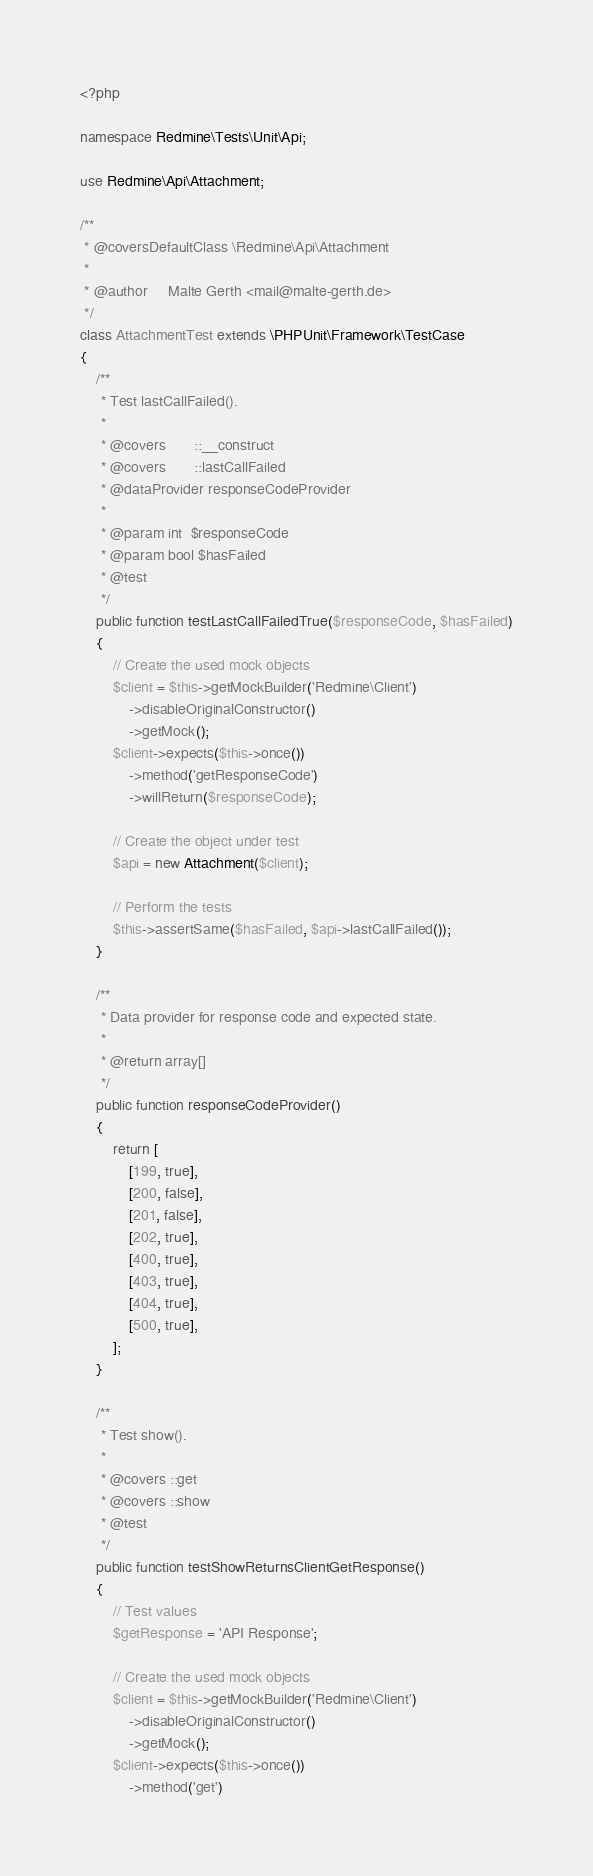Convert code to text. <code><loc_0><loc_0><loc_500><loc_500><_PHP_><?php

namespace Redmine\Tests\Unit\Api;

use Redmine\Api\Attachment;

/**
 * @coversDefaultClass \Redmine\Api\Attachment
 *
 * @author     Malte Gerth <mail@malte-gerth.de>
 */
class AttachmentTest extends \PHPUnit\Framework\TestCase
{
    /**
     * Test lastCallFailed().
     *
     * @covers       ::__construct
     * @covers       ::lastCallFailed
     * @dataProvider responseCodeProvider
     *
     * @param int  $responseCode
     * @param bool $hasFailed
     * @test
     */
    public function testLastCallFailedTrue($responseCode, $hasFailed)
    {
        // Create the used mock objects
        $client = $this->getMockBuilder('Redmine\Client')
            ->disableOriginalConstructor()
            ->getMock();
        $client->expects($this->once())
            ->method('getResponseCode')
            ->willReturn($responseCode);

        // Create the object under test
        $api = new Attachment($client);

        // Perform the tests
        $this->assertSame($hasFailed, $api->lastCallFailed());
    }

    /**
     * Data provider for response code and expected state.
     *
     * @return array[]
     */
    public function responseCodeProvider()
    {
        return [
            [199, true],
            [200, false],
            [201, false],
            [202, true],
            [400, true],
            [403, true],
            [404, true],
            [500, true],
        ];
    }

    /**
     * Test show().
     *
     * @covers ::get
     * @covers ::show
     * @test
     */
    public function testShowReturnsClientGetResponse()
    {
        // Test values
        $getResponse = 'API Response';

        // Create the used mock objects
        $client = $this->getMockBuilder('Redmine\Client')
            ->disableOriginalConstructor()
            ->getMock();
        $client->expects($this->once())
            ->method('get')</code> 